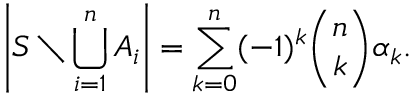Convert formula to latex. <formula><loc_0><loc_0><loc_500><loc_500>\left | S \ \bigcup _ { i = 1 } ^ { n } A _ { i } \right | = \sum _ { k = 0 } ^ { n } ( - 1 ) ^ { k } { \binom { n } { k } } \alpha _ { k } .</formula> 